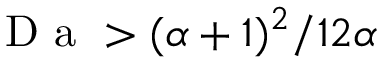<formula> <loc_0><loc_0><loc_500><loc_500>D a > ( \alpha + 1 ) ^ { 2 } / 1 2 \alpha</formula> 